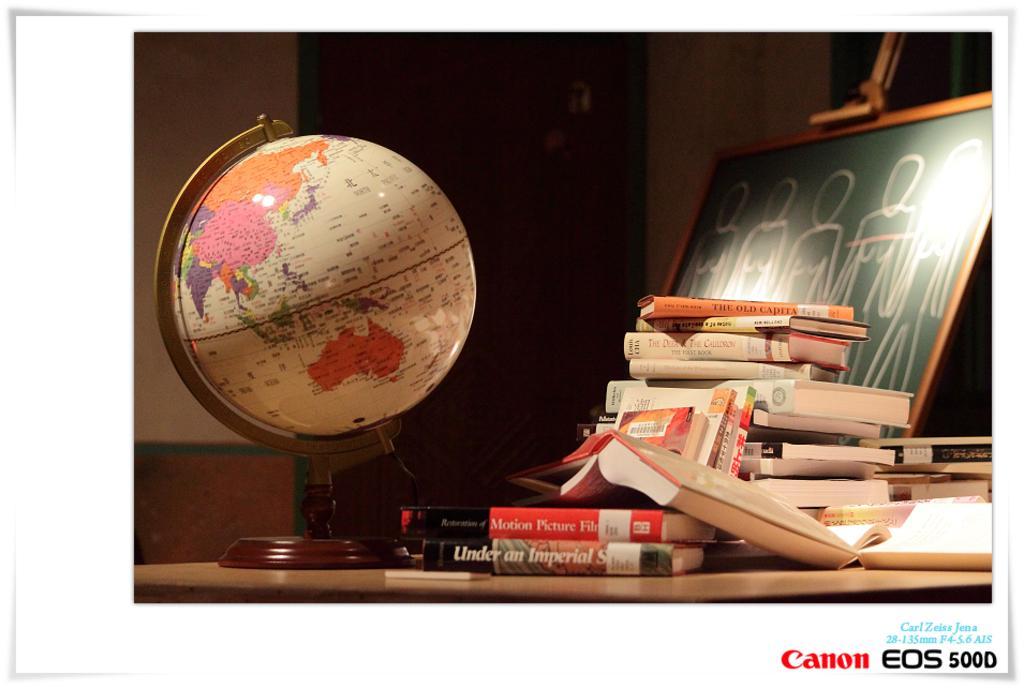Please provide a concise description of this image. This is a poster and in the poster there is a globe, many books, and a green board with few drawing on it. In the background, there is a wall, and a door. 